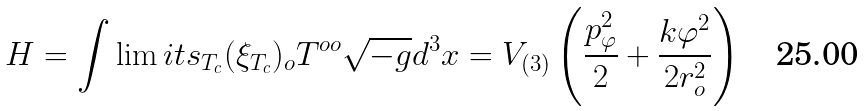<formula> <loc_0><loc_0><loc_500><loc_500>H = \int \lim i t s _ { T _ { c } } ( \xi _ { T _ { c } } ) _ { o } T ^ { o o } \sqrt { - g } d ^ { 3 } x = V _ { ( 3 ) } \left ( \frac { p _ { \varphi } ^ { 2 } } { 2 } + \frac { k \varphi ^ { 2 } } { 2 r _ { o } ^ { 2 } } \right )</formula> 